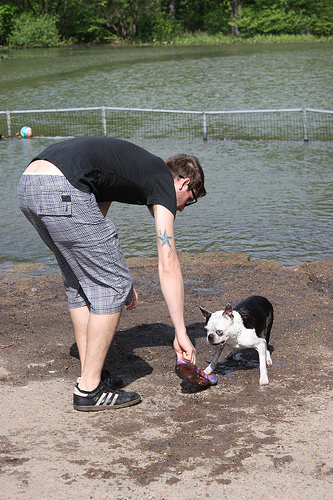<image>
Is there a ball in the water? Yes. The ball is contained within or inside the water, showing a containment relationship. Is the dog in front of the river? Yes. The dog is positioned in front of the river, appearing closer to the camera viewpoint. 